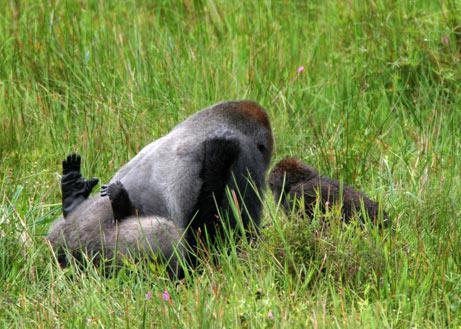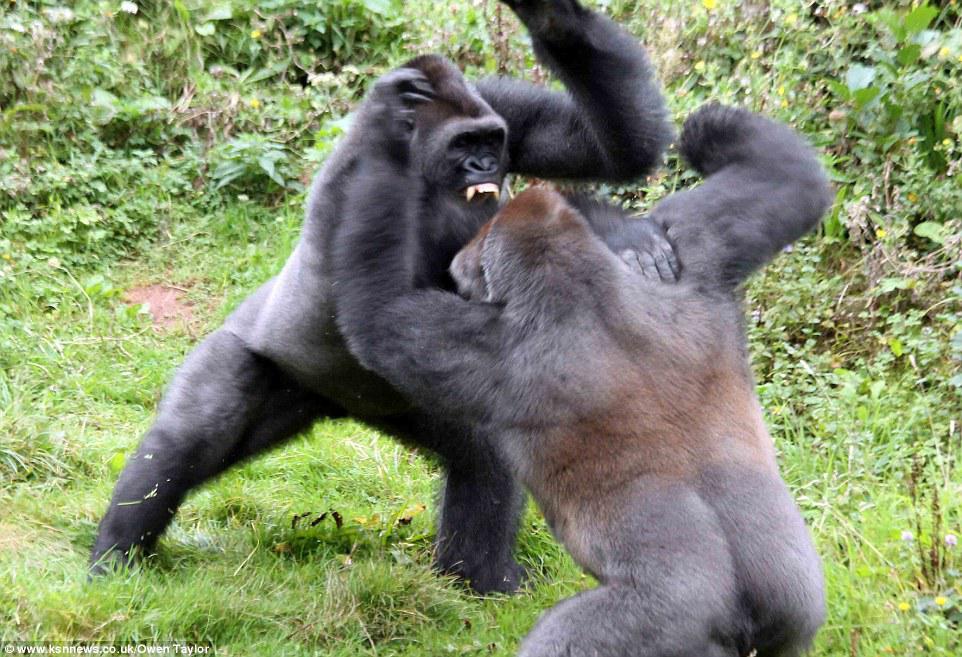The first image is the image on the left, the second image is the image on the right. Analyze the images presented: Is the assertion "The gorillas are fighting." valid? Answer yes or no. Yes. The first image is the image on the left, the second image is the image on the right. Analyze the images presented: Is the assertion "At least one image shows upright gorillas engaged in a confrontation, with at least one gorilla's back turned to the camera and one gorilla with fangs bared." valid? Answer yes or no. Yes. 